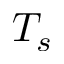Convert formula to latex. <formula><loc_0><loc_0><loc_500><loc_500>T _ { s }</formula> 